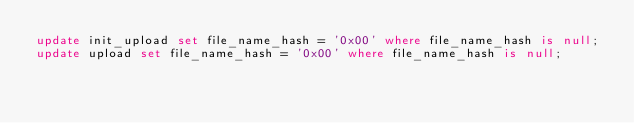Convert code to text. <code><loc_0><loc_0><loc_500><loc_500><_SQL_>update init_upload set file_name_hash = '0x00' where file_name_hash is null;
update upload set file_name_hash = '0x00' where file_name_hash is null;
</code> 